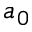<formula> <loc_0><loc_0><loc_500><loc_500>a _ { 0 }</formula> 